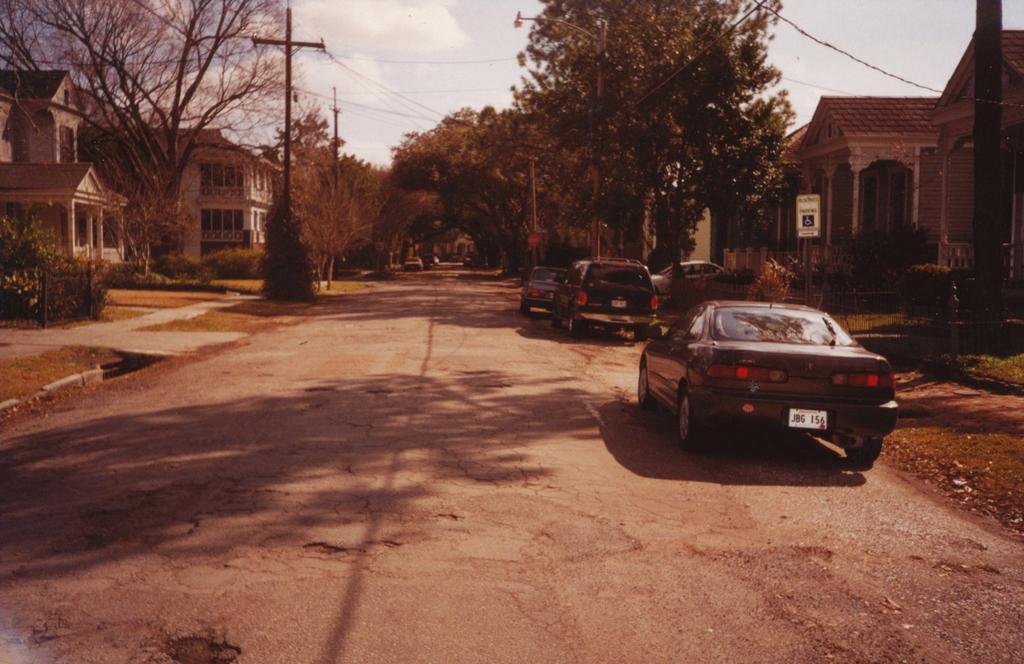How would you summarize this image in a sentence or two? In this image we can see cars on the road. In the background there are trees, poles, buildings and sky. 